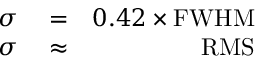Convert formula to latex. <formula><loc_0><loc_0><loc_500><loc_500>\begin{array} { r l r } { \sigma } & = } & { 0 . 4 2 \times F W H M } \\ { \sigma } & \approx } & { R M S } \end{array}</formula> 